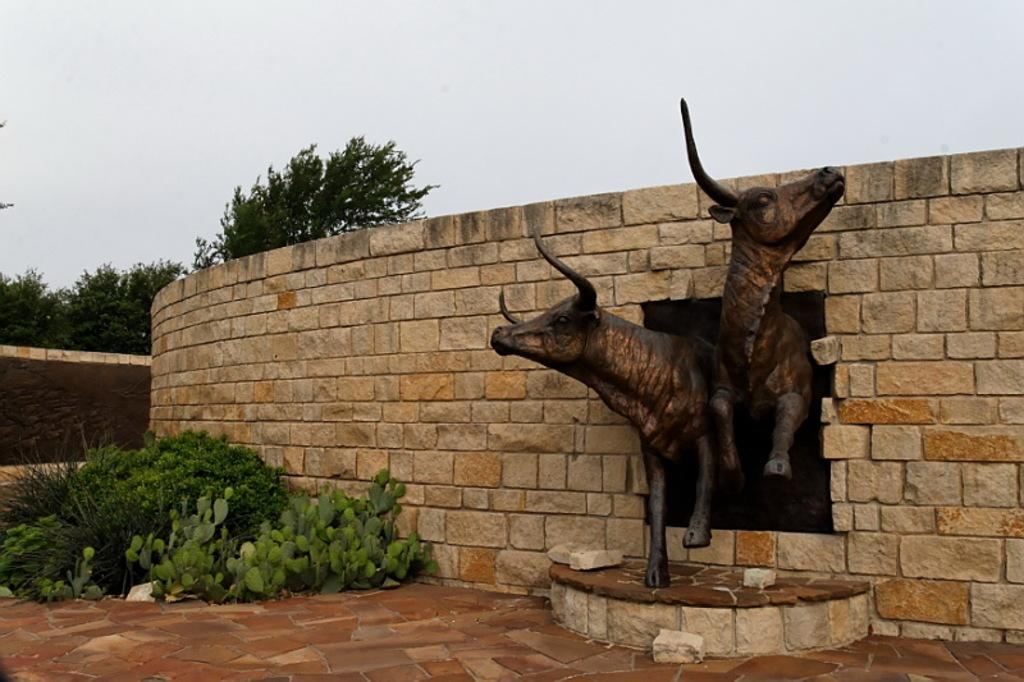What type of objects are depicted as sculptures in the image? There are sculptures of two animals in the image. What is located behind the sculptures? There is a wall in the image. What is placed in front of the wall? There are plants in front of the wall. What can be seen in the distance in the image? There are trees and the sky visible in the background of the image. What type of wax is used to create the sculptures in the image? There is no information about the materials used to create the sculptures in the image, so it cannot be determined if wax was used. 